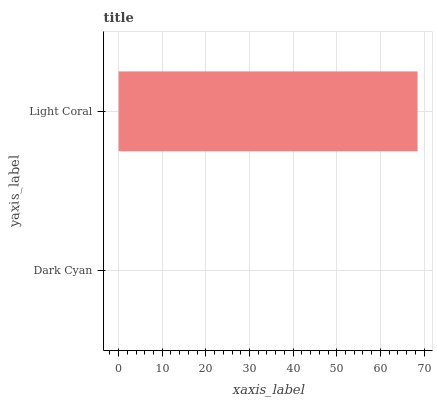Is Dark Cyan the minimum?
Answer yes or no. Yes. Is Light Coral the maximum?
Answer yes or no. Yes. Is Light Coral the minimum?
Answer yes or no. No. Is Light Coral greater than Dark Cyan?
Answer yes or no. Yes. Is Dark Cyan less than Light Coral?
Answer yes or no. Yes. Is Dark Cyan greater than Light Coral?
Answer yes or no. No. Is Light Coral less than Dark Cyan?
Answer yes or no. No. Is Light Coral the high median?
Answer yes or no. Yes. Is Dark Cyan the low median?
Answer yes or no. Yes. Is Dark Cyan the high median?
Answer yes or no. No. Is Light Coral the low median?
Answer yes or no. No. 